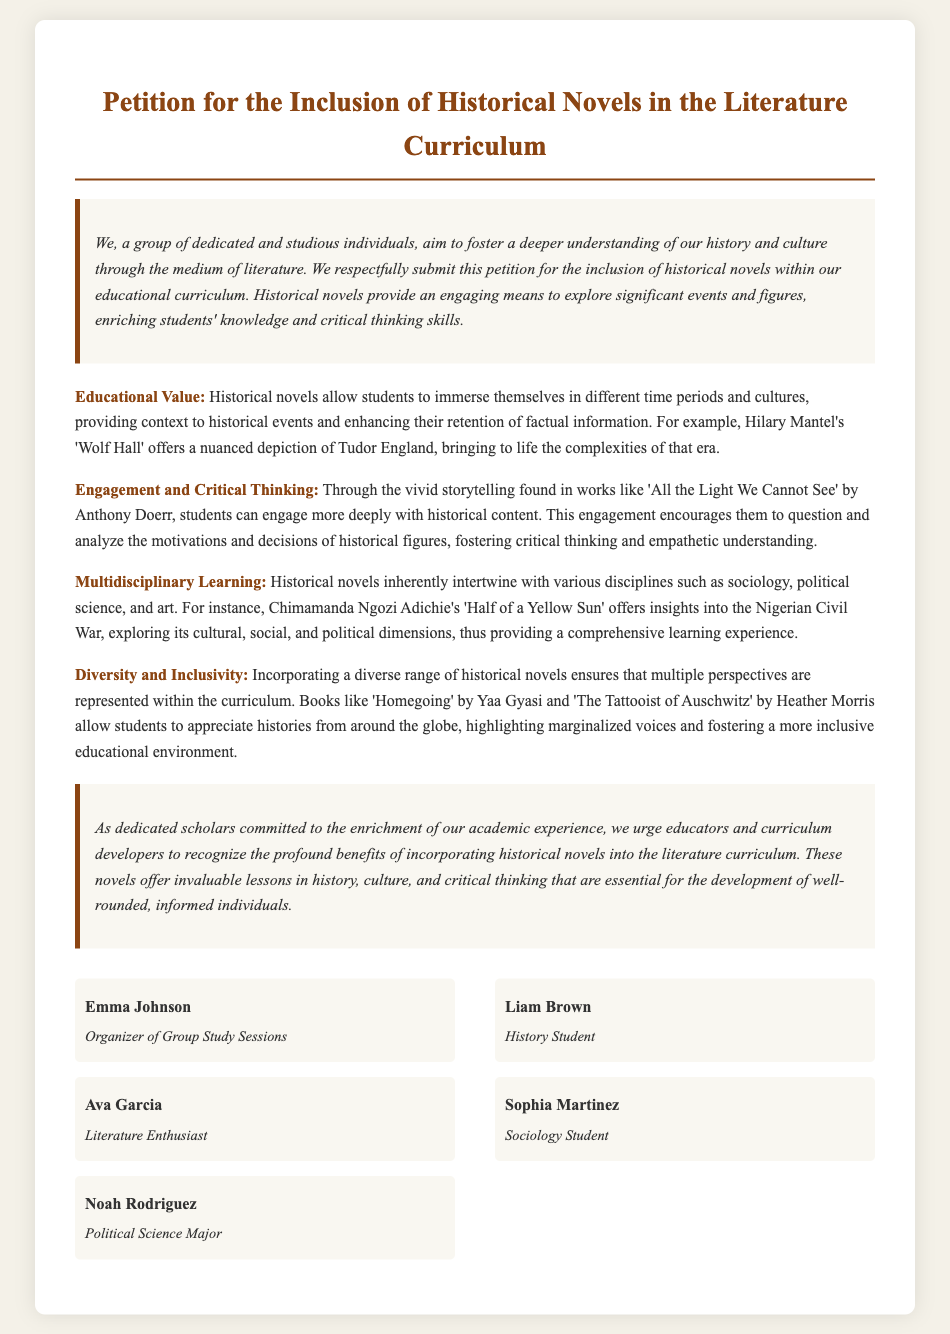what is the title of the petition? The title of the petition is stated clearly at the top of the document.
Answer: Petition for the Inclusion of Historical Novels in the Literature Curriculum who is the organizer of group study sessions? The organizer of group study sessions is listed among the signatories of the petition.
Answer: Emma Johnson name one historical novel mentioned in the petition that explores Tudor England. The petition discusses specific historical novels as examples for educational value.
Answer: Wolf Hall what is one of the reasons for including historical novels in the curriculum? The petition outlines several justifications for the inclusion of historical novels.
Answer: Educational Value how many signatories are listed in the petition? The total number of individuals who have signed the petition can be counted from the signatories section.
Answer: 5 what aspect of learning do historical novels support according to the petition? The petition emphasizes different benefits linked with historical novels and their impact on education.
Answer: Critical Thinking name a novel mentioned in the petition that addresses the Nigerian Civil War. The petition references specific novels to illustrate multidisciplinary learning.
Answer: Half of a Yellow Sun how does the petition propose to enhance diversity in education? The petition discusses how including various historical novels can contribute to a more rounded educational experience.
Answer: By incorporating diverse perspectives what type of document is this? The nature of the document indicates its purpose and format within academic and social engagement.
Answer: Petition 